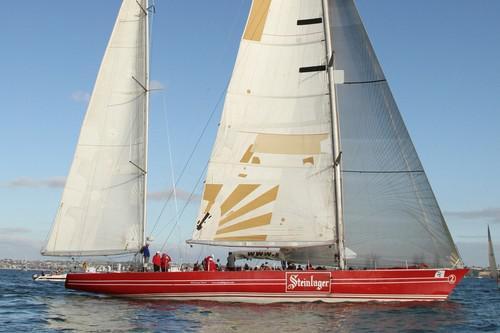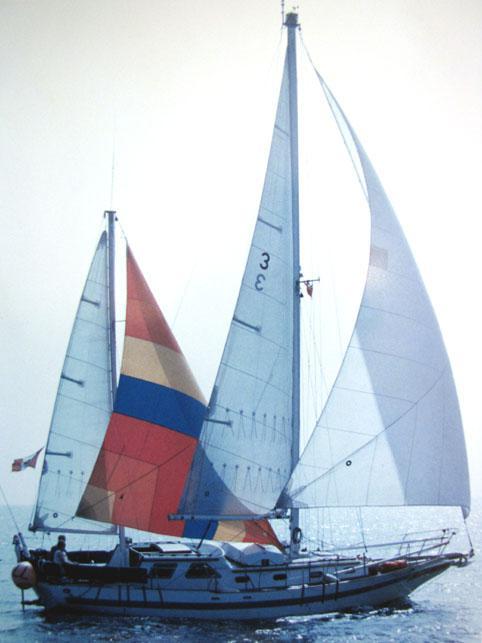The first image is the image on the left, the second image is the image on the right. Given the left and right images, does the statement "There appear to be fewer than four people on each boat." hold true? Answer yes or no. No. 